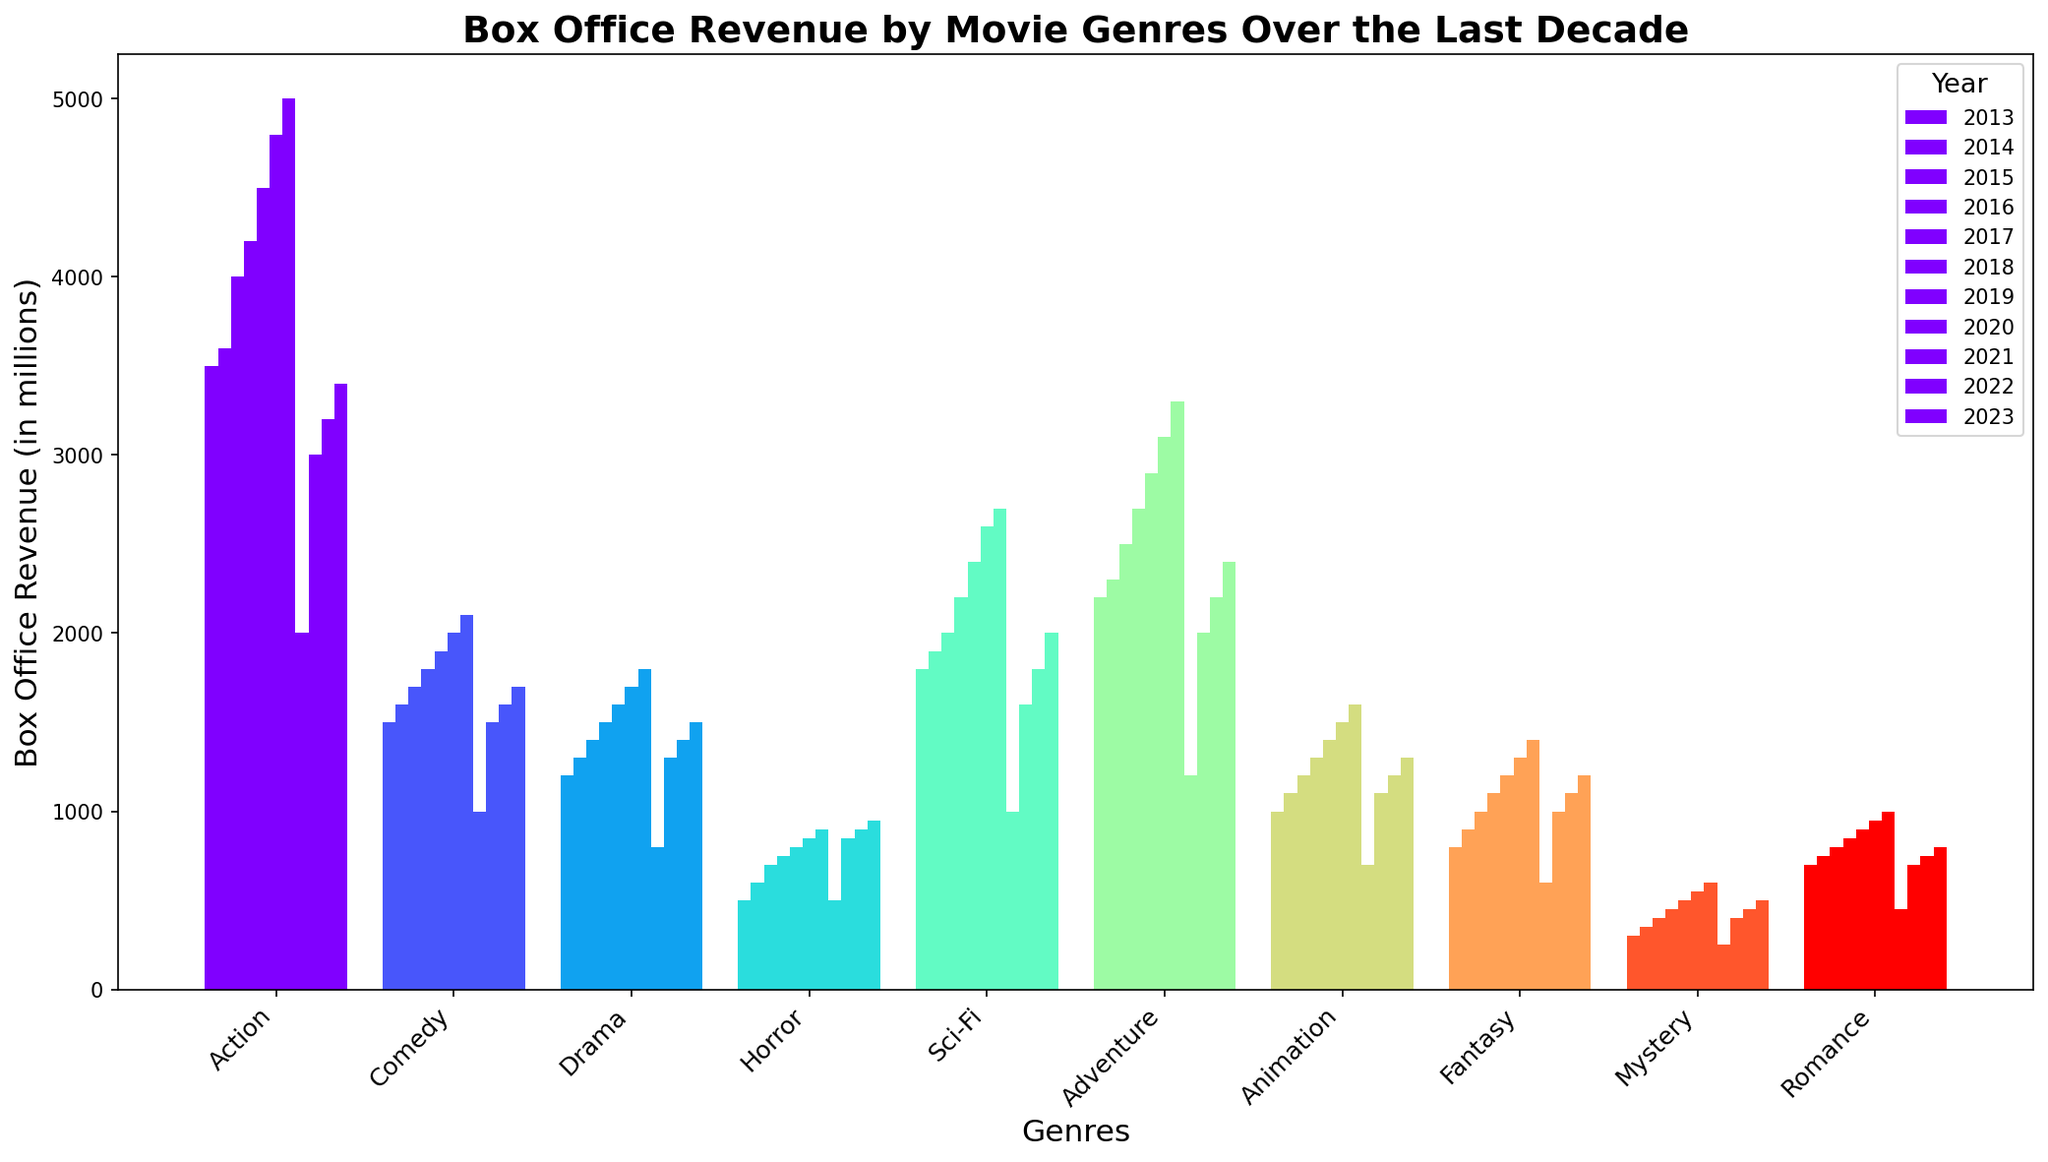Which genre had the highest box office revenue in 2019? By examining the height of the bars for 2019, the genre with the highest revenue can be identified. The tallest bar corresponds to Action.
Answer: Action What is the total box office revenue for the Drama genre over the last decade? To find this, sum up the values from 2013 to 2023 for Drama: 1200 + 1300 + 1400 + 1500 + 1600 + 1700 + 1800 + 800 + 1300 + 1400 + 1500. Thus, the total is 15,500.
Answer: 15,500 Which year did Action movies make the least revenue? By comparing the heights of the bars for Action genre across all years, the shortest bar is in 2020.
Answer: 2020 How did the revenue for Comedy movies change from 2019 to 2020? Check the height of the bars for Comedy in 2019 and 2020 and find the difference: 2100 - 1000 = 1100. So, the revenue dropped by 1100 million.
Answer: Dropped by 1100 million In 2022, which genres earned less than 1000 million at the box office? By observing the bar heights for 2022, the genres with bars lower than the 1000 million mark are Mystery and Romance.
Answer: Mystery, Romance What is the average annual revenue of Sci-Fi movies from 2013 to 2023? Add up the annual revenues for Sci-Fi: 1800 + 1900 + 2000 + 2200 + 2400 + 2600 + 2700 + 1000 + 1600 + 1800 + 2000. Then divide by 11: the total is 24,000; 24,000 / 11 = approx. 2182 million.
Answer: Approximately 2182 million Which genre had the most consistent box office revenue trends over the last decade? Evaluating consistency involves examining genres with the most uniform bar heights. Drama appears to have the most consistent revenue across the years.
Answer: Drama Did any genre surpass the 5000 million mark in revenue in any single year? Inspect each bar for all genres in each year. None of the bars exceed the 5000 million mark, indicating no genre surpassed it.
Answer: No Compare the total revenue of Horror and Romance from 2013 to 2023. Which one is higher and by how much? Sum the revenues for Horror and Romance. For Horror: 500 + 600 + 700 + 750 + 800 + 850 + 900 + 500 + 850 + 900 + 950 = 8300. For Romance: 700 + 750 + 800 + 850 + 900 + 950 + 1000 + 450 + 700 + 750 + 800 = 8650. Hence, Romance exceeds Horror by 350 million.
Answer: Romance, by 350 million What are the top three genres with the highest revenues in 2023? By evaluating the heights of the bars in 2023, the top three are Action, Sci-Fi, and Adventure.
Answer: Action, Sci-Fi, Adventure 